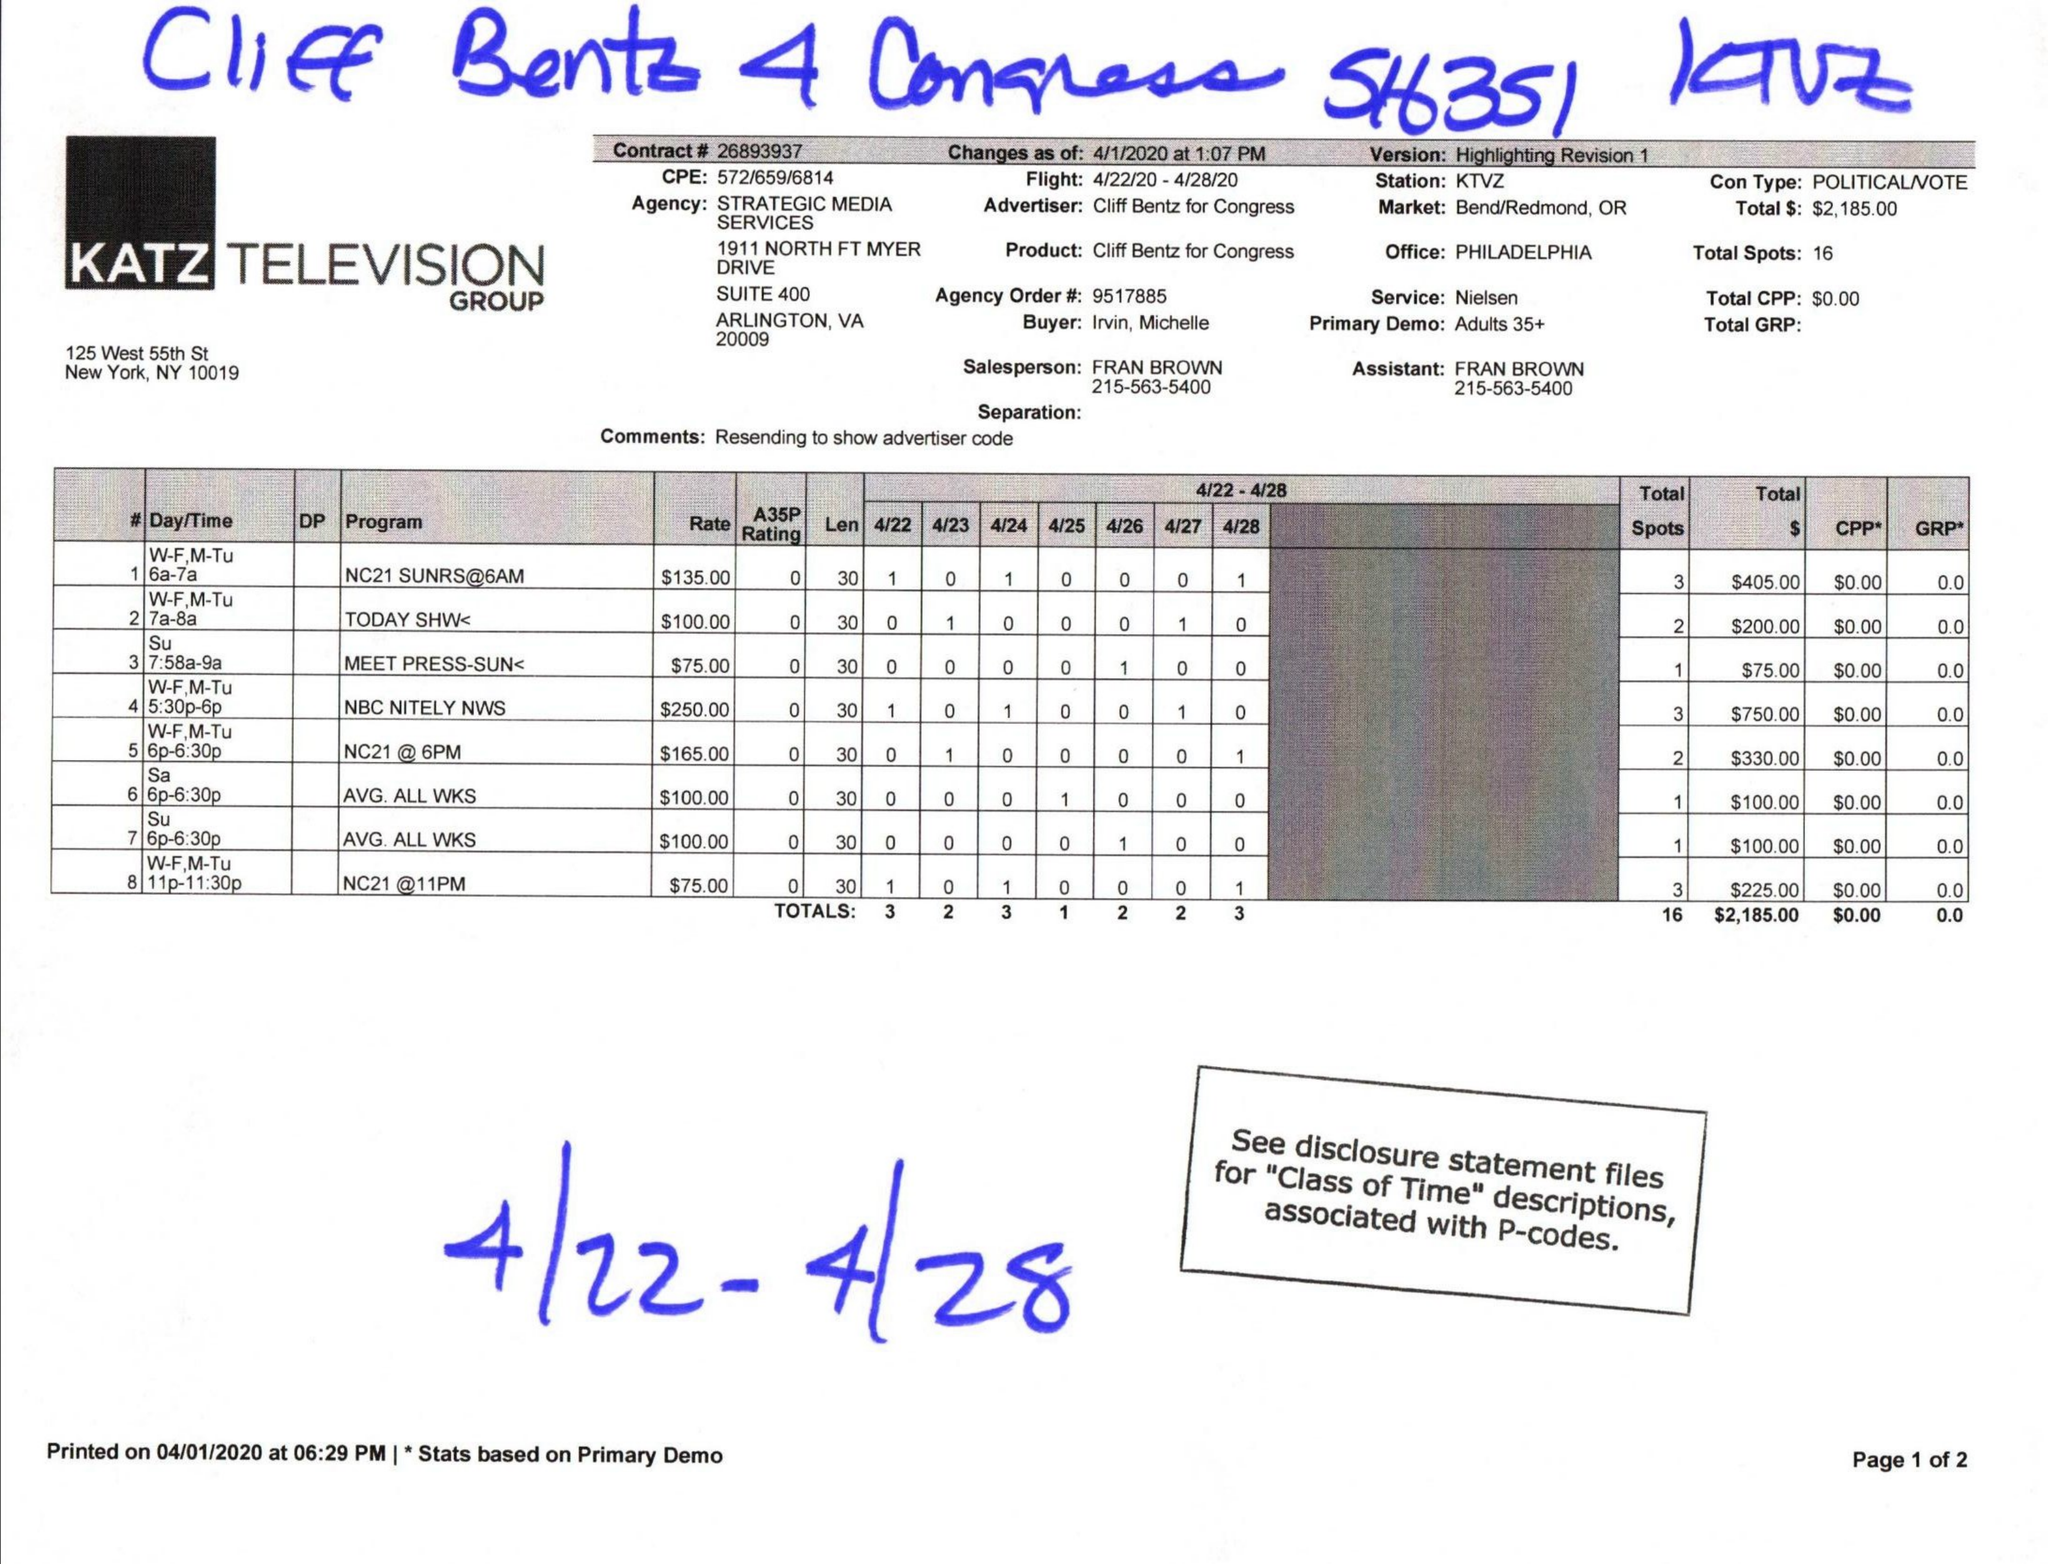What is the value for the flight_to?
Answer the question using a single word or phrase. 04/28/20 